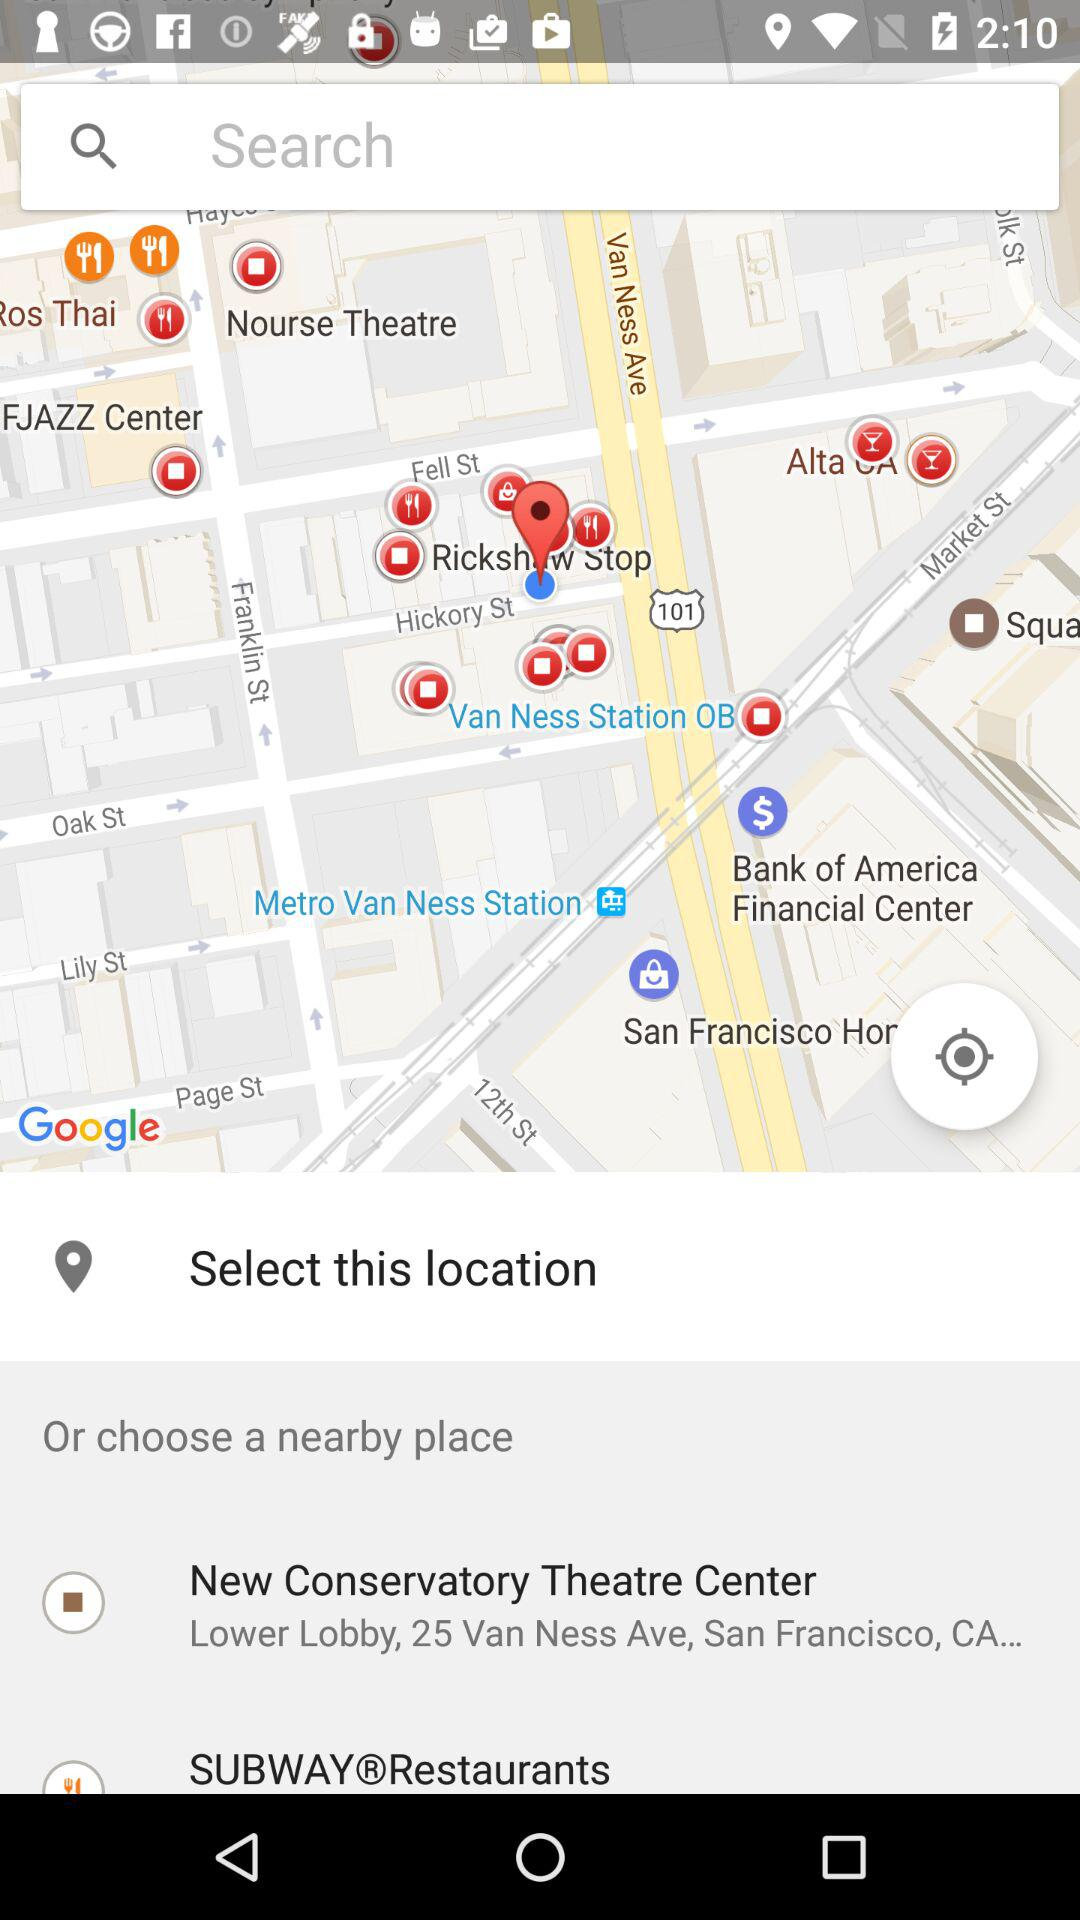What is the address of the "Theatre Center"? The address of the "Theatre Center" is "Lower Lobby, 25 Van Ness Ave, San Francisco, CA...". 